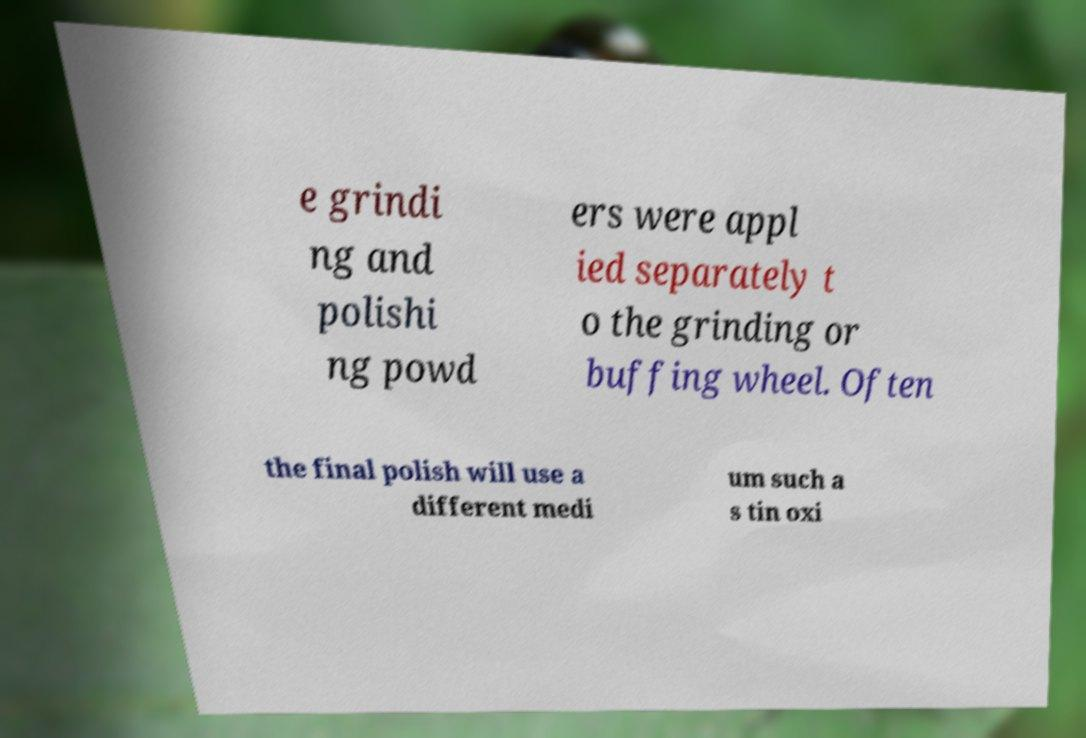Could you extract and type out the text from this image? e grindi ng and polishi ng powd ers were appl ied separately t o the grinding or buffing wheel. Often the final polish will use a different medi um such a s tin oxi 